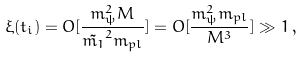Convert formula to latex. <formula><loc_0><loc_0><loc_500><loc_500>\xi ( t _ { i } ) = O [ \frac { m _ { \psi } ^ { 2 } M } { \tilde { m _ { 1 } } ^ { 2 } m _ { p l } } ] = O [ \frac { m _ { \psi } ^ { 2 } m _ { p l } } { M ^ { 3 } } ] \gg 1 \, ,</formula> 